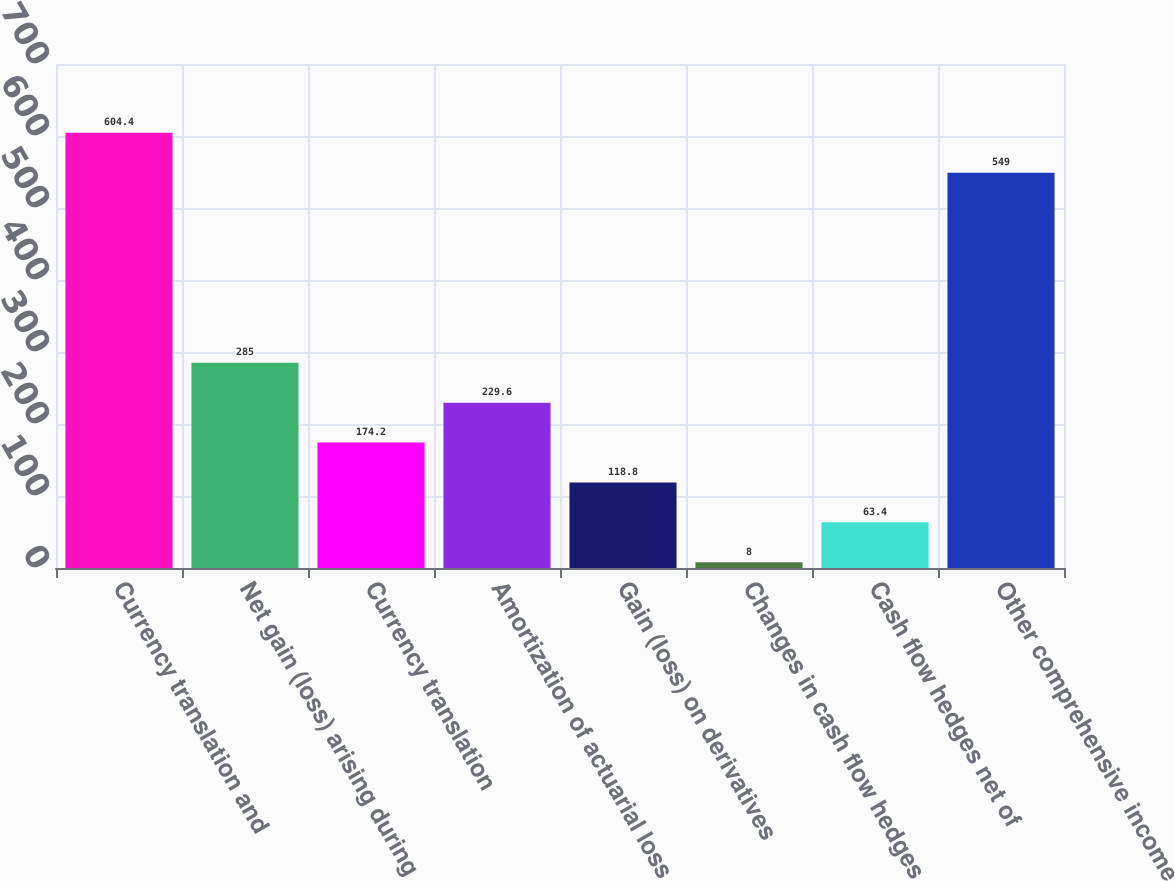Convert chart. <chart><loc_0><loc_0><loc_500><loc_500><bar_chart><fcel>Currency translation and<fcel>Net gain (loss) arising during<fcel>Currency translation<fcel>Amortization of actuarial loss<fcel>Gain (loss) on derivatives<fcel>Changes in cash flow hedges<fcel>Cash flow hedges net of<fcel>Other comprehensive income<nl><fcel>604.4<fcel>285<fcel>174.2<fcel>229.6<fcel>118.8<fcel>8<fcel>63.4<fcel>549<nl></chart> 